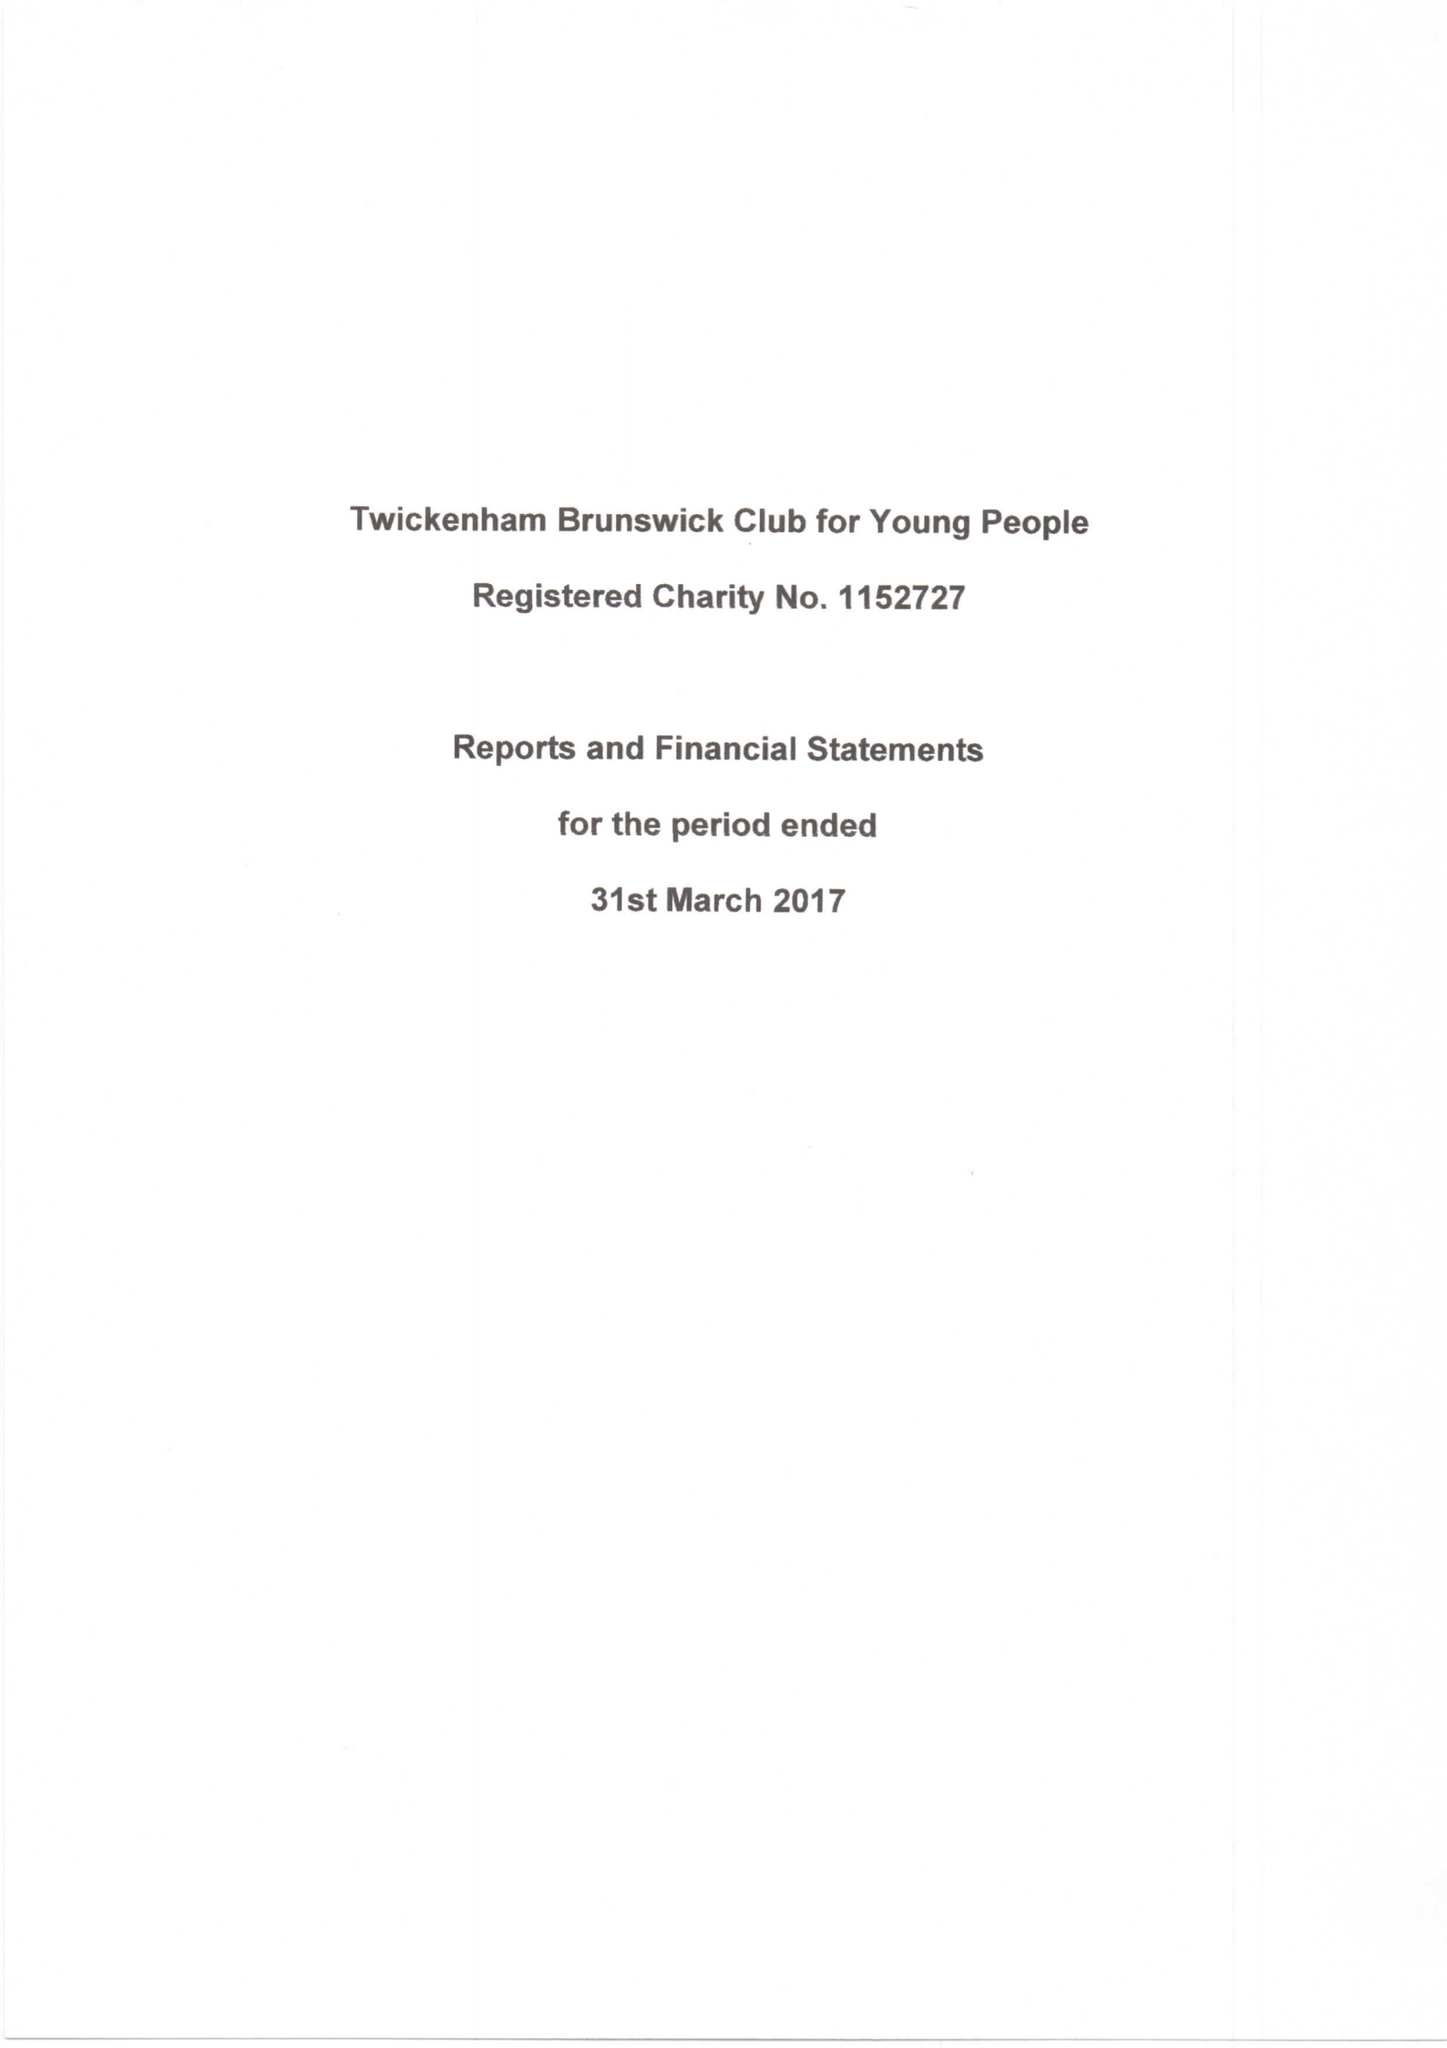What is the value for the spending_annually_in_british_pounds?
Answer the question using a single word or phrase. 74628.00 